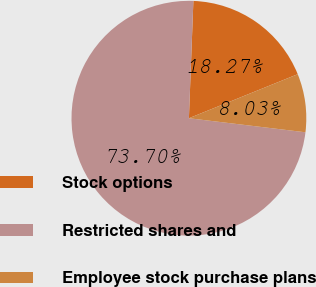Convert chart. <chart><loc_0><loc_0><loc_500><loc_500><pie_chart><fcel>Stock options<fcel>Restricted shares and<fcel>Employee stock purchase plans<nl><fcel>18.27%<fcel>73.69%<fcel>8.03%<nl></chart> 